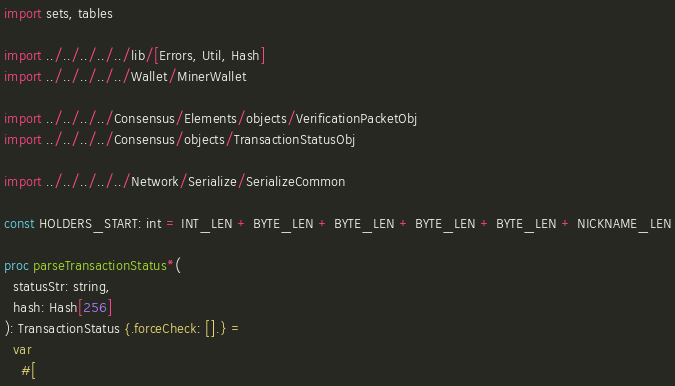Convert code to text. <code><loc_0><loc_0><loc_500><loc_500><_Nim_>import sets, tables

import ../../../../../lib/[Errors, Util, Hash]
import ../../../../../Wallet/MinerWallet

import ../../../../Consensus/Elements/objects/VerificationPacketObj
import ../../../../Consensus/objects/TransactionStatusObj

import ../../../../../Network/Serialize/SerializeCommon

const HOLDERS_START: int = INT_LEN + BYTE_LEN + BYTE_LEN + BYTE_LEN + BYTE_LEN + NICKNAME_LEN

proc parseTransactionStatus*(
  statusStr: string,
  hash: Hash[256]
): TransactionStatus {.forceCheck: [].} =
  var
    #[</code> 